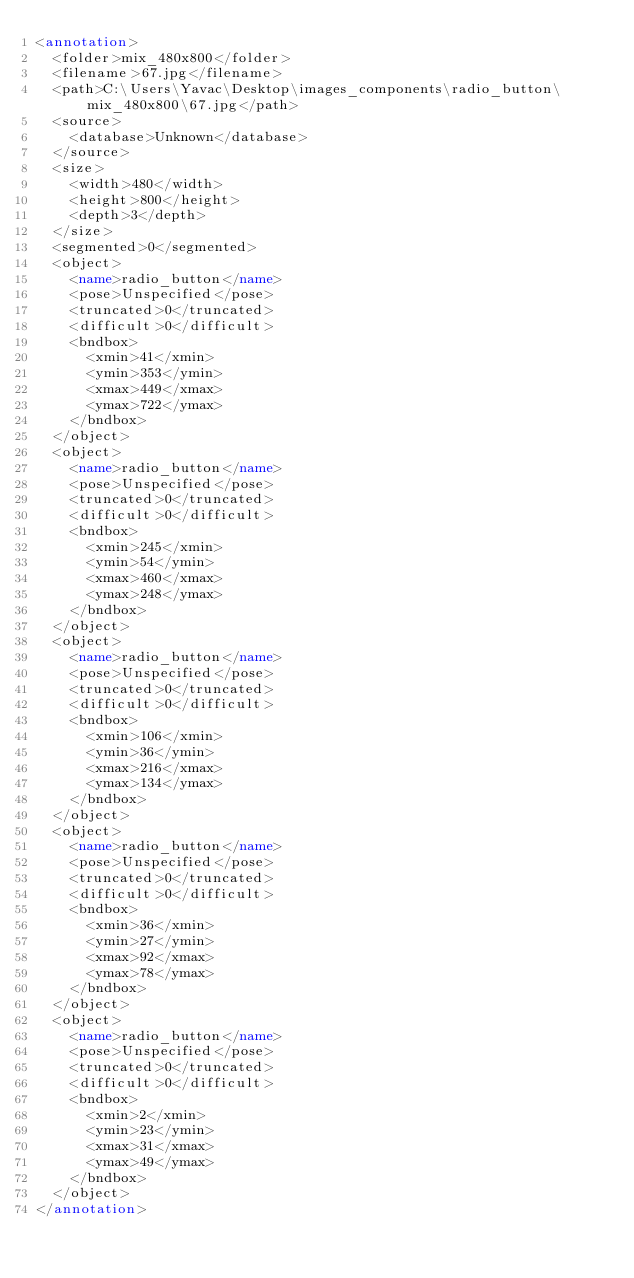<code> <loc_0><loc_0><loc_500><loc_500><_XML_><annotation>
	<folder>mix_480x800</folder>
	<filename>67.jpg</filename>
	<path>C:\Users\Yavac\Desktop\images_components\radio_button\mix_480x800\67.jpg</path>
	<source>
		<database>Unknown</database>
	</source>
	<size>
		<width>480</width>
		<height>800</height>
		<depth>3</depth>
	</size>
	<segmented>0</segmented>
	<object>
		<name>radio_button</name>
		<pose>Unspecified</pose>
		<truncated>0</truncated>
		<difficult>0</difficult>
		<bndbox>
			<xmin>41</xmin>
			<ymin>353</ymin>
			<xmax>449</xmax>
			<ymax>722</ymax>
		</bndbox>
	</object>
	<object>
		<name>radio_button</name>
		<pose>Unspecified</pose>
		<truncated>0</truncated>
		<difficult>0</difficult>
		<bndbox>
			<xmin>245</xmin>
			<ymin>54</ymin>
			<xmax>460</xmax>
			<ymax>248</ymax>
		</bndbox>
	</object>
	<object>
		<name>radio_button</name>
		<pose>Unspecified</pose>
		<truncated>0</truncated>
		<difficult>0</difficult>
		<bndbox>
			<xmin>106</xmin>
			<ymin>36</ymin>
			<xmax>216</xmax>
			<ymax>134</ymax>
		</bndbox>
	</object>
	<object>
		<name>radio_button</name>
		<pose>Unspecified</pose>
		<truncated>0</truncated>
		<difficult>0</difficult>
		<bndbox>
			<xmin>36</xmin>
			<ymin>27</ymin>
			<xmax>92</xmax>
			<ymax>78</ymax>
		</bndbox>
	</object>
	<object>
		<name>radio_button</name>
		<pose>Unspecified</pose>
		<truncated>0</truncated>
		<difficult>0</difficult>
		<bndbox>
			<xmin>2</xmin>
			<ymin>23</ymin>
			<xmax>31</xmax>
			<ymax>49</ymax>
		</bndbox>
	</object>
</annotation>
</code> 